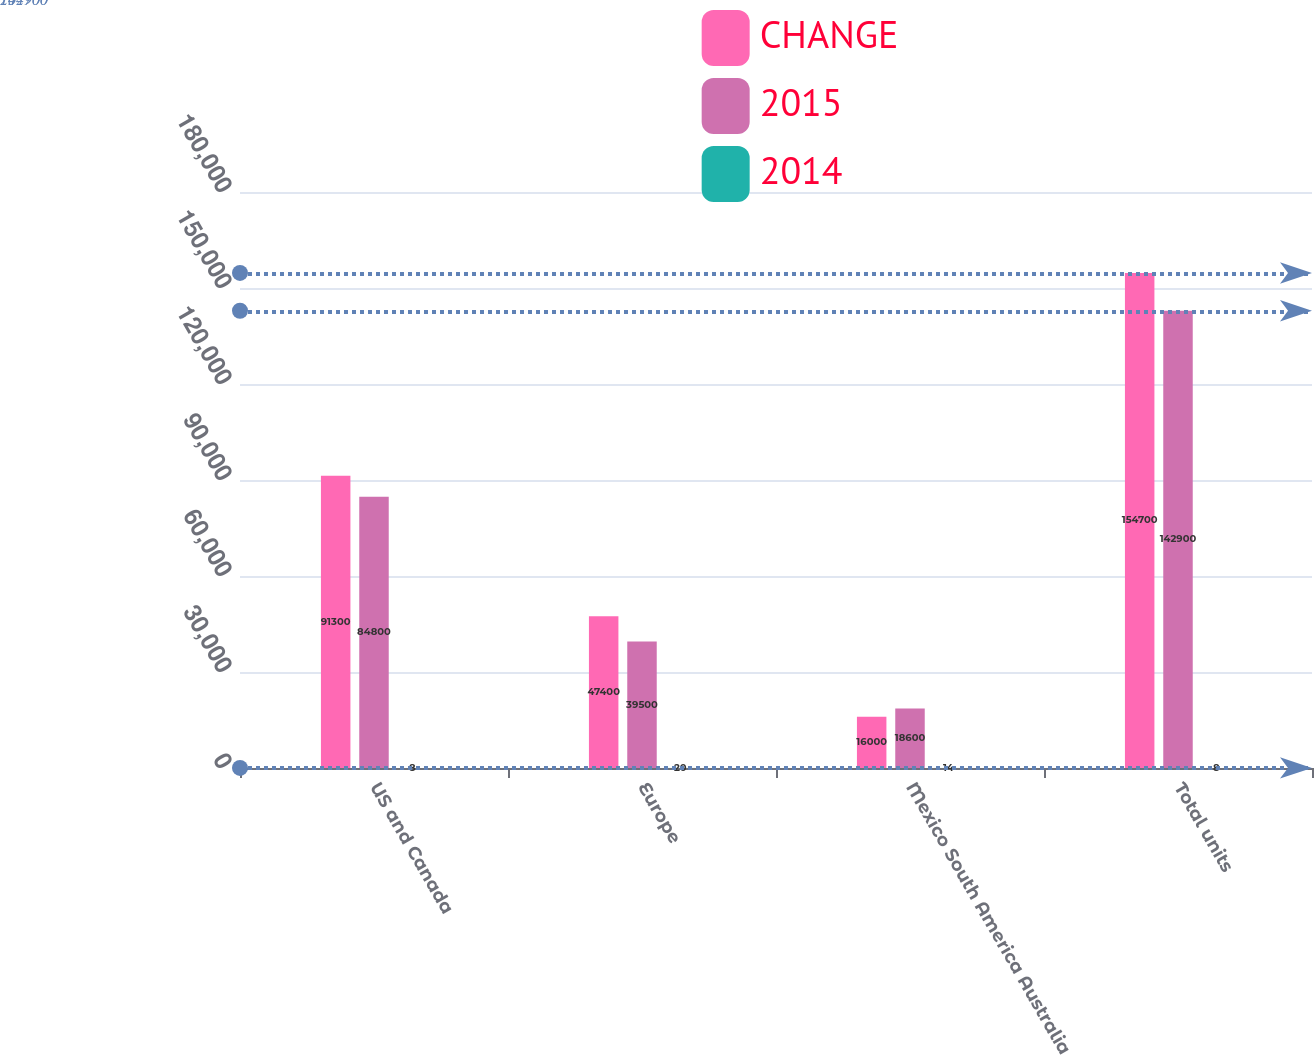Convert chart to OTSL. <chart><loc_0><loc_0><loc_500><loc_500><stacked_bar_chart><ecel><fcel>US and Canada<fcel>Europe<fcel>Mexico South America Australia<fcel>Total units<nl><fcel>CHANGE<fcel>91300<fcel>47400<fcel>16000<fcel>154700<nl><fcel>2015<fcel>84800<fcel>39500<fcel>18600<fcel>142900<nl><fcel>2014<fcel>8<fcel>20<fcel>14<fcel>8<nl></chart> 